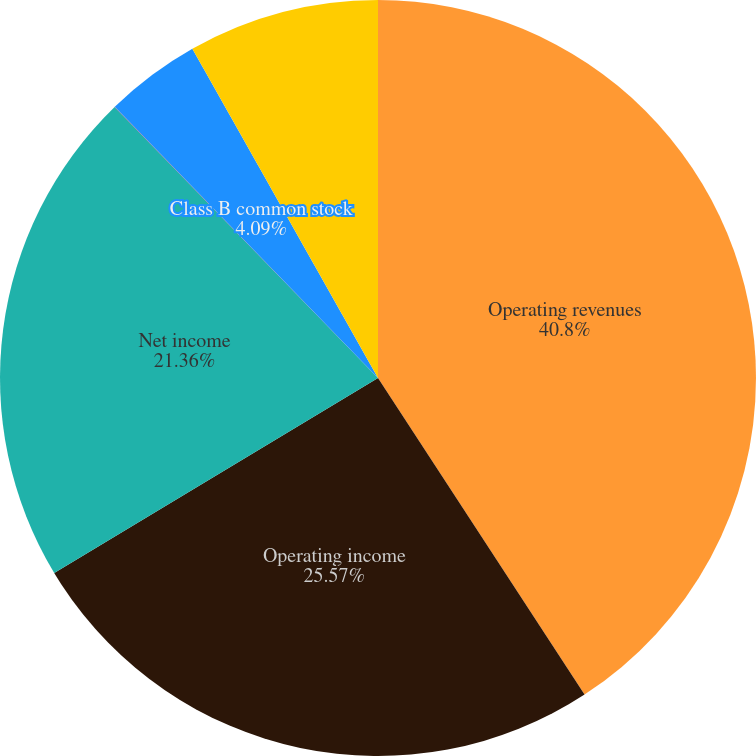Convert chart to OTSL. <chart><loc_0><loc_0><loc_500><loc_500><pie_chart><fcel>Operating revenues<fcel>Operating income<fcel>Net income<fcel>Class A common stock<fcel>Class B common stock<fcel>Class C common stock<nl><fcel>40.8%<fcel>25.57%<fcel>21.36%<fcel>0.01%<fcel>4.09%<fcel>8.17%<nl></chart> 